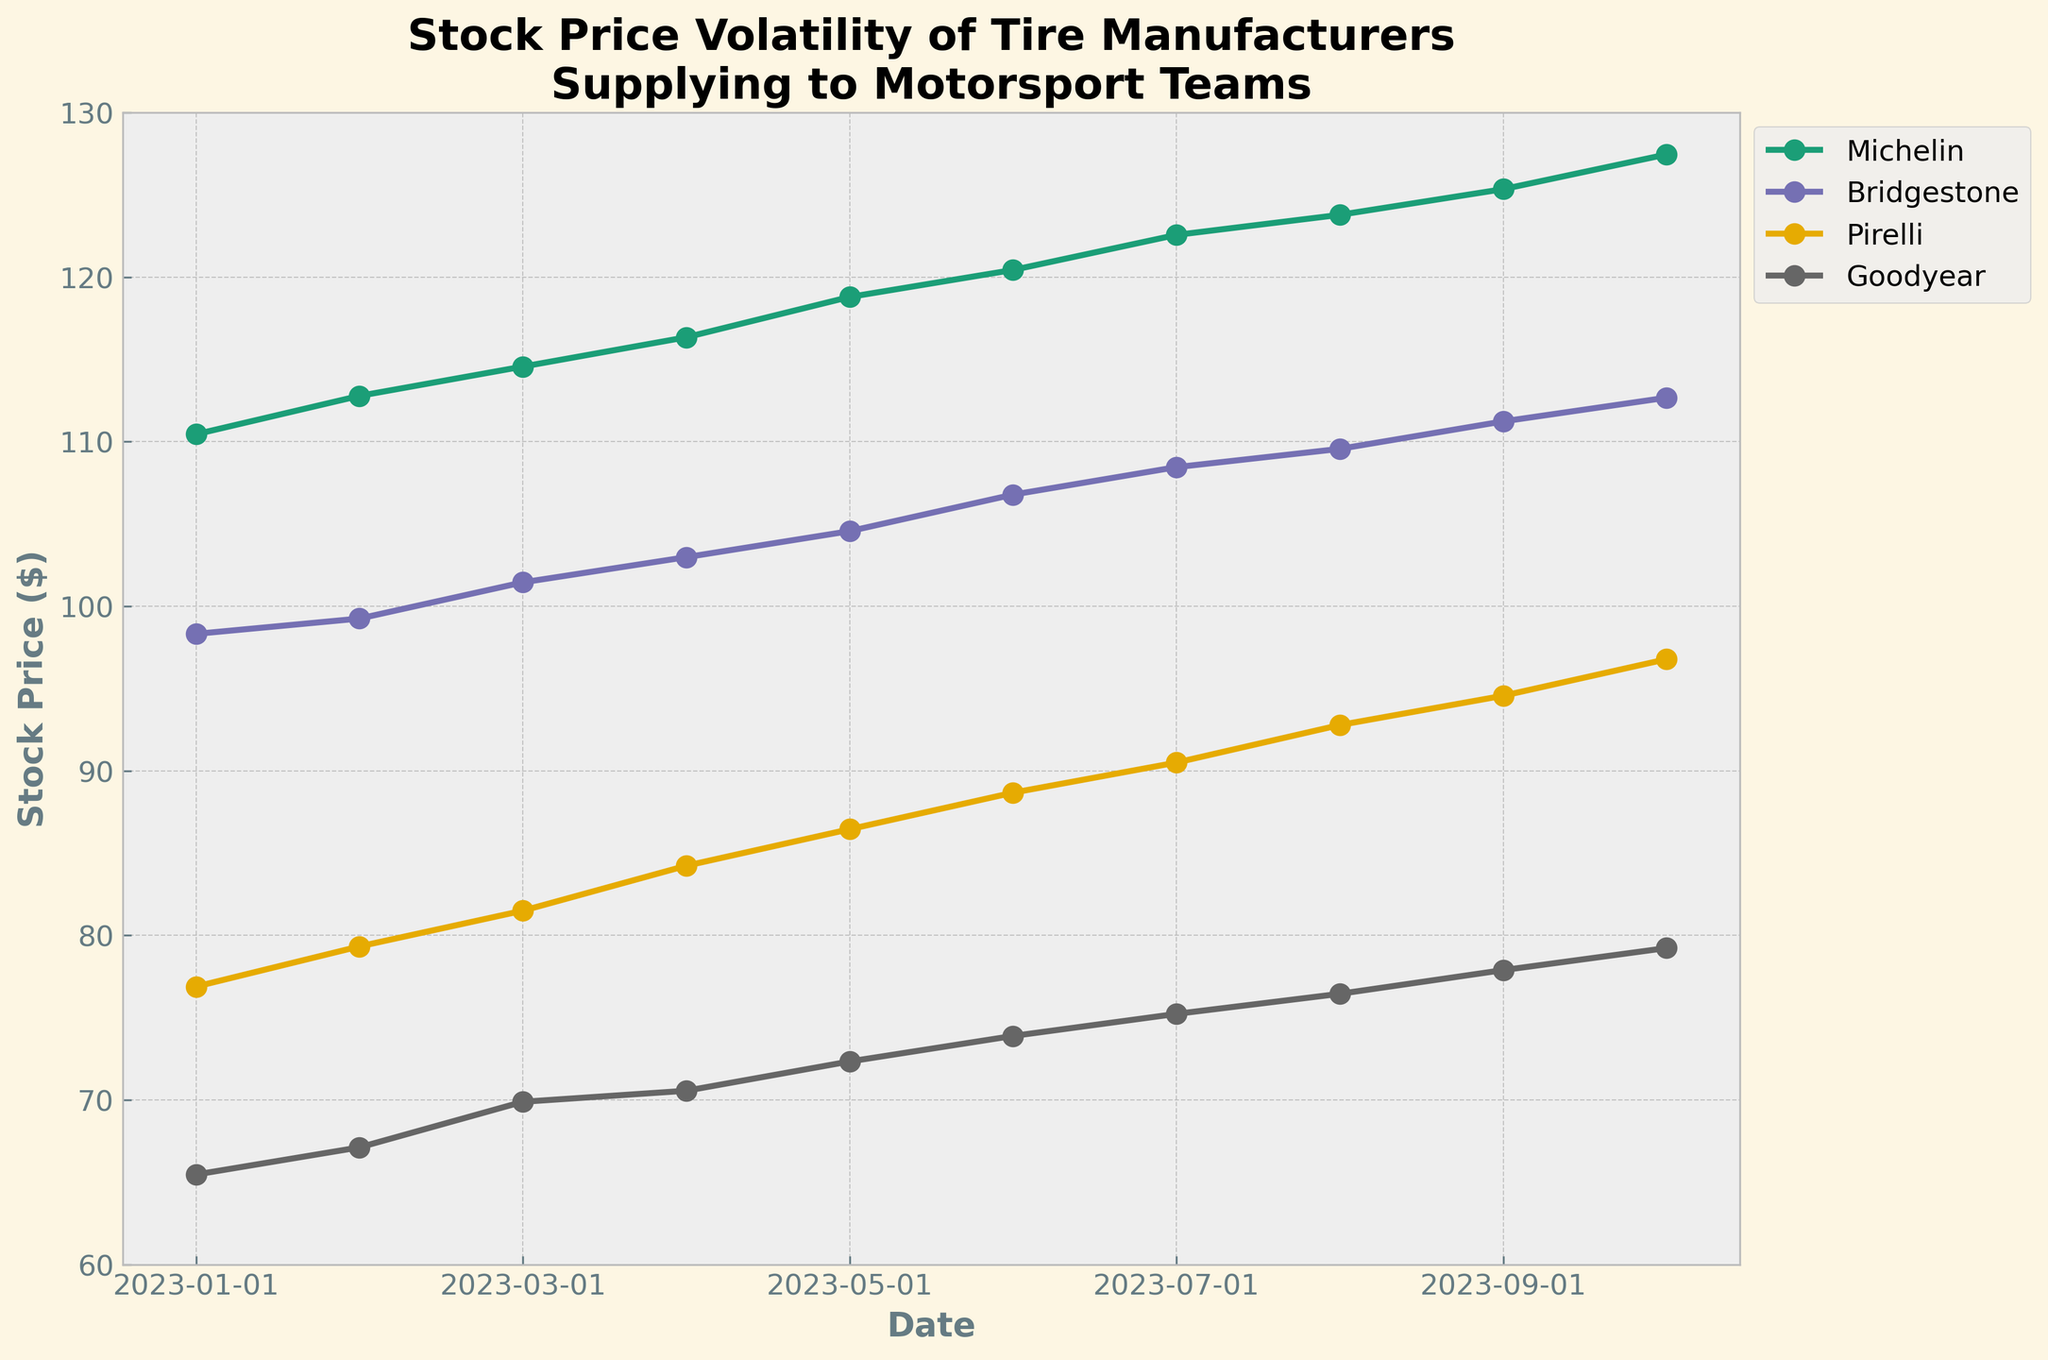What is the title of the plot? The title of the plot is usually located at the top center of the figure. In this case, it reads "Stock Price Volatility of Tire Manufacturers Supplying to Motorsport Teams."
Answer: Stock Price Volatility of Tire Manufacturers Supplying to Motorsport Teams What are the manufacturers listed in the plot? The manufacturers listed in the plot can be identified by their distinct lines and labels in the legend. The plot includes Michelin, Bridgestone, Pirelli, and Goodyear.
Answer: Michelin, Bridgestone, Pirelli, Goodyear What is the stock price of Michelin on 2023-07-01? By following the Michelin line (which can be identified by its color and label) to the data point corresponding to 2023-07-01, we can see that the stock price of Michelin on that date is 122.56.
Answer: 122.56 Which manufacturer had the highest stock price in October 2023? By comparing the stock prices of all manufacturers in October 2023 (2023-10-01), we see that Michelin had the highest stock price at 127.45.
Answer: Michelin What is the difference in stock price between Bridgestone and Goodyear on 2023-09-01? To find the difference, identify the stock prices for Bridgestone and Goodyear on 2023-09-01: 111.23 and 77.89, respectively. The difference is 111.23 - 77.89.
Answer: 33.34 How did the stock price of Pirelli change from January 2023 to October 2023? Look at the stock prices of Pirelli on 2023-01-01 (76.89) and 2023-10-01 (96.78). The change is 96.78 - 76.89, which can be found by subtracting the initial value from the final value.
Answer: Increased by 19.89 Which month did Goodyear experience the highest increase in stock price compared to the previous month? Examine the stock prices for Goodyear month by month to find the greatest month-to-month increase. Calculate the differences and find the highest difference: 2023-03-01 to 2023-04-01 is 70.56 - 69.89 = 0.67; 2023-04-01 to 2023-05-01 is 72.34 - 70.56 = 1.78; the highest increase is from 2023-02-01 to 2023-03-01 which is 69.89 - 67.12 = 2.77.
Answer: March 2023 What is the average stock price of Bridgestone from January 2023 to October 2023? Sum the stock prices of Bridgestone from each month: 98.32 + 99.25 + 101.45 + 102.98 + 104.56 + 106.78 + 108.45 + 109.56 + 111.23 + 112.67 = 1055.25. Then divide by the number of months (10).
Answer: 105.53 How does the stock price trend of Michelin compare to Pirelli over the given period? Compare the overall direction (upward, downward, or stable) of the stock prices of Michelin and Pirelli. Both manufacturers show an upward trend, but Michelin's increase is more significant in magnitude and consistency.
Answer: Both upward, Michelin more significant 